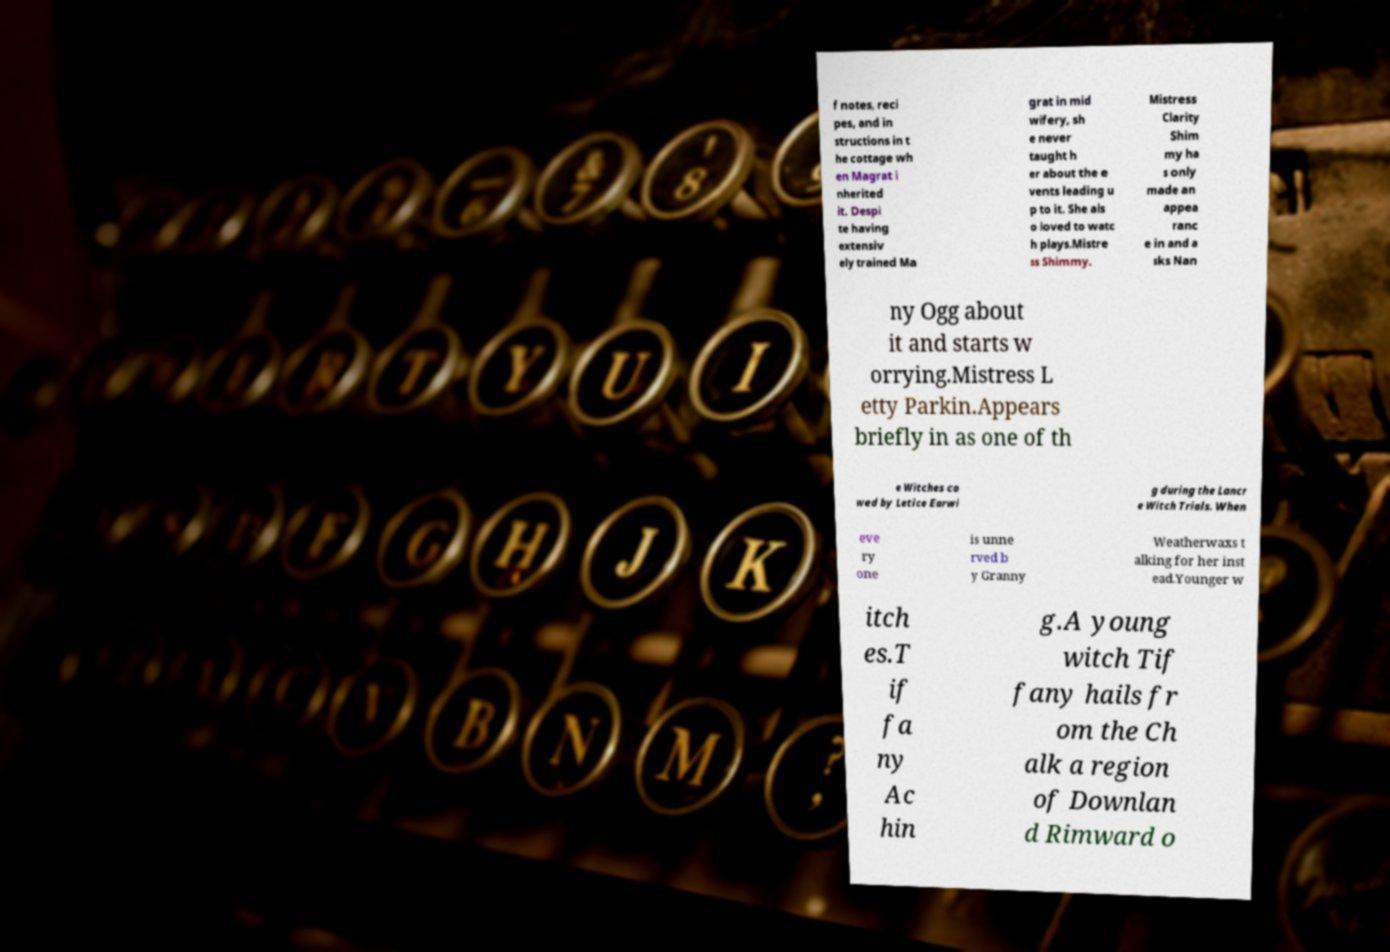Please read and relay the text visible in this image. What does it say? f notes, reci pes, and in structions in t he cottage wh en Magrat i nherited it. Despi te having extensiv ely trained Ma grat in mid wifery, sh e never taught h er about the e vents leading u p to it. She als o loved to watc h plays.Mistre ss Shimmy. Mistress Clarity Shim my ha s only made an appea ranc e in and a sks Nan ny Ogg about it and starts w orrying.Mistress L etty Parkin.Appears briefly in as one of th e Witches co wed by Letice Earwi g during the Lancr e Witch Trials. When eve ry one is unne rved b y Granny Weatherwaxs t alking for her inst ead.Younger w itch es.T if fa ny Ac hin g.A young witch Tif fany hails fr om the Ch alk a region of Downlan d Rimward o 